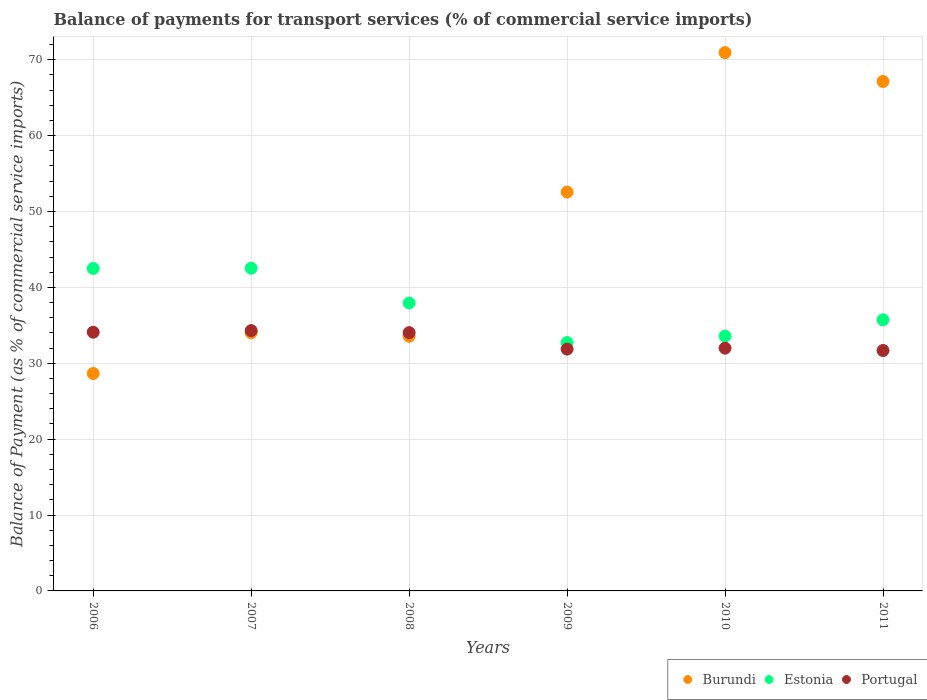Is the number of dotlines equal to the number of legend labels?
Ensure brevity in your answer.  Yes. What is the balance of payments for transport services in Portugal in 2007?
Provide a short and direct response. 34.3. Across all years, what is the maximum balance of payments for transport services in Portugal?
Keep it short and to the point. 34.3. Across all years, what is the minimum balance of payments for transport services in Portugal?
Provide a short and direct response. 31.68. In which year was the balance of payments for transport services in Burundi maximum?
Give a very brief answer. 2010. What is the total balance of payments for transport services in Portugal in the graph?
Provide a short and direct response. 197.95. What is the difference between the balance of payments for transport services in Estonia in 2006 and that in 2007?
Offer a terse response. -0.03. What is the difference between the balance of payments for transport services in Portugal in 2006 and the balance of payments for transport services in Burundi in 2008?
Make the answer very short. 0.53. What is the average balance of payments for transport services in Portugal per year?
Offer a very short reply. 32.99. In the year 2008, what is the difference between the balance of payments for transport services in Burundi and balance of payments for transport services in Portugal?
Your response must be concise. -0.47. In how many years, is the balance of payments for transport services in Burundi greater than 16 %?
Make the answer very short. 6. What is the ratio of the balance of payments for transport services in Burundi in 2006 to that in 2010?
Keep it short and to the point. 0.4. Is the balance of payments for transport services in Portugal in 2009 less than that in 2010?
Your answer should be compact. Yes. Is the difference between the balance of payments for transport services in Burundi in 2007 and 2009 greater than the difference between the balance of payments for transport services in Portugal in 2007 and 2009?
Your answer should be very brief. No. What is the difference between the highest and the second highest balance of payments for transport services in Portugal?
Keep it short and to the point. 0.21. What is the difference between the highest and the lowest balance of payments for transport services in Burundi?
Give a very brief answer. 42.28. Is the sum of the balance of payments for transport services in Estonia in 2010 and 2011 greater than the maximum balance of payments for transport services in Portugal across all years?
Your answer should be compact. Yes. Is it the case that in every year, the sum of the balance of payments for transport services in Portugal and balance of payments for transport services in Estonia  is greater than the balance of payments for transport services in Burundi?
Keep it short and to the point. No. Is the balance of payments for transport services in Estonia strictly greater than the balance of payments for transport services in Portugal over the years?
Keep it short and to the point. Yes. How many dotlines are there?
Provide a succinct answer. 3. Are the values on the major ticks of Y-axis written in scientific E-notation?
Your response must be concise. No. Does the graph contain any zero values?
Make the answer very short. No. Does the graph contain grids?
Your answer should be compact. Yes. Where does the legend appear in the graph?
Provide a succinct answer. Bottom right. How many legend labels are there?
Provide a succinct answer. 3. What is the title of the graph?
Keep it short and to the point. Balance of payments for transport services (% of commercial service imports). Does "Iceland" appear as one of the legend labels in the graph?
Your answer should be compact. No. What is the label or title of the Y-axis?
Your answer should be very brief. Balance of Payment (as % of commercial service imports). What is the Balance of Payment (as % of commercial service imports) of Burundi in 2006?
Offer a very short reply. 28.65. What is the Balance of Payment (as % of commercial service imports) of Estonia in 2006?
Ensure brevity in your answer.  42.49. What is the Balance of Payment (as % of commercial service imports) of Portugal in 2006?
Offer a terse response. 34.09. What is the Balance of Payment (as % of commercial service imports) of Burundi in 2007?
Ensure brevity in your answer.  34.02. What is the Balance of Payment (as % of commercial service imports) of Estonia in 2007?
Your answer should be very brief. 42.52. What is the Balance of Payment (as % of commercial service imports) in Portugal in 2007?
Your answer should be very brief. 34.3. What is the Balance of Payment (as % of commercial service imports) of Burundi in 2008?
Provide a short and direct response. 33.56. What is the Balance of Payment (as % of commercial service imports) in Estonia in 2008?
Give a very brief answer. 37.94. What is the Balance of Payment (as % of commercial service imports) of Portugal in 2008?
Offer a terse response. 34.03. What is the Balance of Payment (as % of commercial service imports) in Burundi in 2009?
Ensure brevity in your answer.  52.56. What is the Balance of Payment (as % of commercial service imports) in Estonia in 2009?
Your answer should be very brief. 32.73. What is the Balance of Payment (as % of commercial service imports) of Portugal in 2009?
Keep it short and to the point. 31.86. What is the Balance of Payment (as % of commercial service imports) in Burundi in 2010?
Offer a very short reply. 70.93. What is the Balance of Payment (as % of commercial service imports) of Estonia in 2010?
Keep it short and to the point. 33.58. What is the Balance of Payment (as % of commercial service imports) of Portugal in 2010?
Offer a terse response. 31.99. What is the Balance of Payment (as % of commercial service imports) of Burundi in 2011?
Make the answer very short. 67.13. What is the Balance of Payment (as % of commercial service imports) in Estonia in 2011?
Make the answer very short. 35.73. What is the Balance of Payment (as % of commercial service imports) of Portugal in 2011?
Provide a succinct answer. 31.68. Across all years, what is the maximum Balance of Payment (as % of commercial service imports) in Burundi?
Ensure brevity in your answer.  70.93. Across all years, what is the maximum Balance of Payment (as % of commercial service imports) in Estonia?
Keep it short and to the point. 42.52. Across all years, what is the maximum Balance of Payment (as % of commercial service imports) in Portugal?
Your answer should be very brief. 34.3. Across all years, what is the minimum Balance of Payment (as % of commercial service imports) in Burundi?
Your response must be concise. 28.65. Across all years, what is the minimum Balance of Payment (as % of commercial service imports) in Estonia?
Provide a short and direct response. 32.73. Across all years, what is the minimum Balance of Payment (as % of commercial service imports) in Portugal?
Offer a very short reply. 31.68. What is the total Balance of Payment (as % of commercial service imports) of Burundi in the graph?
Your response must be concise. 286.85. What is the total Balance of Payment (as % of commercial service imports) in Estonia in the graph?
Your response must be concise. 224.98. What is the total Balance of Payment (as % of commercial service imports) of Portugal in the graph?
Provide a succinct answer. 197.95. What is the difference between the Balance of Payment (as % of commercial service imports) of Burundi in 2006 and that in 2007?
Give a very brief answer. -5.37. What is the difference between the Balance of Payment (as % of commercial service imports) in Estonia in 2006 and that in 2007?
Your answer should be compact. -0.03. What is the difference between the Balance of Payment (as % of commercial service imports) of Portugal in 2006 and that in 2007?
Give a very brief answer. -0.21. What is the difference between the Balance of Payment (as % of commercial service imports) of Burundi in 2006 and that in 2008?
Offer a terse response. -4.91. What is the difference between the Balance of Payment (as % of commercial service imports) in Estonia in 2006 and that in 2008?
Ensure brevity in your answer.  4.55. What is the difference between the Balance of Payment (as % of commercial service imports) of Portugal in 2006 and that in 2008?
Provide a short and direct response. 0.06. What is the difference between the Balance of Payment (as % of commercial service imports) in Burundi in 2006 and that in 2009?
Keep it short and to the point. -23.9. What is the difference between the Balance of Payment (as % of commercial service imports) in Estonia in 2006 and that in 2009?
Your response must be concise. 9.76. What is the difference between the Balance of Payment (as % of commercial service imports) in Portugal in 2006 and that in 2009?
Your answer should be compact. 2.23. What is the difference between the Balance of Payment (as % of commercial service imports) of Burundi in 2006 and that in 2010?
Your answer should be very brief. -42.28. What is the difference between the Balance of Payment (as % of commercial service imports) of Estonia in 2006 and that in 2010?
Make the answer very short. 8.91. What is the difference between the Balance of Payment (as % of commercial service imports) of Portugal in 2006 and that in 2010?
Your response must be concise. 2.1. What is the difference between the Balance of Payment (as % of commercial service imports) of Burundi in 2006 and that in 2011?
Make the answer very short. -38.48. What is the difference between the Balance of Payment (as % of commercial service imports) in Estonia in 2006 and that in 2011?
Provide a succinct answer. 6.76. What is the difference between the Balance of Payment (as % of commercial service imports) of Portugal in 2006 and that in 2011?
Provide a succinct answer. 2.41. What is the difference between the Balance of Payment (as % of commercial service imports) of Burundi in 2007 and that in 2008?
Ensure brevity in your answer.  0.46. What is the difference between the Balance of Payment (as % of commercial service imports) of Estonia in 2007 and that in 2008?
Your response must be concise. 4.58. What is the difference between the Balance of Payment (as % of commercial service imports) of Portugal in 2007 and that in 2008?
Provide a succinct answer. 0.27. What is the difference between the Balance of Payment (as % of commercial service imports) of Burundi in 2007 and that in 2009?
Offer a very short reply. -18.54. What is the difference between the Balance of Payment (as % of commercial service imports) in Estonia in 2007 and that in 2009?
Provide a short and direct response. 9.79. What is the difference between the Balance of Payment (as % of commercial service imports) in Portugal in 2007 and that in 2009?
Your response must be concise. 2.44. What is the difference between the Balance of Payment (as % of commercial service imports) in Burundi in 2007 and that in 2010?
Offer a terse response. -36.91. What is the difference between the Balance of Payment (as % of commercial service imports) in Estonia in 2007 and that in 2010?
Your response must be concise. 8.94. What is the difference between the Balance of Payment (as % of commercial service imports) of Portugal in 2007 and that in 2010?
Your response must be concise. 2.31. What is the difference between the Balance of Payment (as % of commercial service imports) in Burundi in 2007 and that in 2011?
Offer a very short reply. -33.11. What is the difference between the Balance of Payment (as % of commercial service imports) of Estonia in 2007 and that in 2011?
Your response must be concise. 6.79. What is the difference between the Balance of Payment (as % of commercial service imports) in Portugal in 2007 and that in 2011?
Your answer should be compact. 2.62. What is the difference between the Balance of Payment (as % of commercial service imports) of Burundi in 2008 and that in 2009?
Give a very brief answer. -18.99. What is the difference between the Balance of Payment (as % of commercial service imports) in Estonia in 2008 and that in 2009?
Your answer should be compact. 5.21. What is the difference between the Balance of Payment (as % of commercial service imports) in Portugal in 2008 and that in 2009?
Offer a terse response. 2.17. What is the difference between the Balance of Payment (as % of commercial service imports) in Burundi in 2008 and that in 2010?
Provide a short and direct response. -37.37. What is the difference between the Balance of Payment (as % of commercial service imports) in Estonia in 2008 and that in 2010?
Your answer should be compact. 4.36. What is the difference between the Balance of Payment (as % of commercial service imports) of Portugal in 2008 and that in 2010?
Offer a terse response. 2.05. What is the difference between the Balance of Payment (as % of commercial service imports) of Burundi in 2008 and that in 2011?
Provide a succinct answer. -33.57. What is the difference between the Balance of Payment (as % of commercial service imports) in Estonia in 2008 and that in 2011?
Keep it short and to the point. 2.21. What is the difference between the Balance of Payment (as % of commercial service imports) in Portugal in 2008 and that in 2011?
Provide a succinct answer. 2.36. What is the difference between the Balance of Payment (as % of commercial service imports) of Burundi in 2009 and that in 2010?
Your answer should be very brief. -18.38. What is the difference between the Balance of Payment (as % of commercial service imports) in Estonia in 2009 and that in 2010?
Make the answer very short. -0.85. What is the difference between the Balance of Payment (as % of commercial service imports) of Portugal in 2009 and that in 2010?
Provide a short and direct response. -0.13. What is the difference between the Balance of Payment (as % of commercial service imports) of Burundi in 2009 and that in 2011?
Provide a succinct answer. -14.58. What is the difference between the Balance of Payment (as % of commercial service imports) in Estonia in 2009 and that in 2011?
Provide a short and direct response. -3. What is the difference between the Balance of Payment (as % of commercial service imports) in Portugal in 2009 and that in 2011?
Your answer should be compact. 0.18. What is the difference between the Balance of Payment (as % of commercial service imports) of Burundi in 2010 and that in 2011?
Keep it short and to the point. 3.8. What is the difference between the Balance of Payment (as % of commercial service imports) of Estonia in 2010 and that in 2011?
Your response must be concise. -2.15. What is the difference between the Balance of Payment (as % of commercial service imports) in Portugal in 2010 and that in 2011?
Your response must be concise. 0.31. What is the difference between the Balance of Payment (as % of commercial service imports) in Burundi in 2006 and the Balance of Payment (as % of commercial service imports) in Estonia in 2007?
Provide a succinct answer. -13.87. What is the difference between the Balance of Payment (as % of commercial service imports) in Burundi in 2006 and the Balance of Payment (as % of commercial service imports) in Portugal in 2007?
Your answer should be compact. -5.65. What is the difference between the Balance of Payment (as % of commercial service imports) in Estonia in 2006 and the Balance of Payment (as % of commercial service imports) in Portugal in 2007?
Make the answer very short. 8.19. What is the difference between the Balance of Payment (as % of commercial service imports) of Burundi in 2006 and the Balance of Payment (as % of commercial service imports) of Estonia in 2008?
Offer a very short reply. -9.29. What is the difference between the Balance of Payment (as % of commercial service imports) in Burundi in 2006 and the Balance of Payment (as % of commercial service imports) in Portugal in 2008?
Provide a succinct answer. -5.38. What is the difference between the Balance of Payment (as % of commercial service imports) in Estonia in 2006 and the Balance of Payment (as % of commercial service imports) in Portugal in 2008?
Offer a terse response. 8.46. What is the difference between the Balance of Payment (as % of commercial service imports) of Burundi in 2006 and the Balance of Payment (as % of commercial service imports) of Estonia in 2009?
Offer a terse response. -4.08. What is the difference between the Balance of Payment (as % of commercial service imports) of Burundi in 2006 and the Balance of Payment (as % of commercial service imports) of Portugal in 2009?
Provide a short and direct response. -3.21. What is the difference between the Balance of Payment (as % of commercial service imports) of Estonia in 2006 and the Balance of Payment (as % of commercial service imports) of Portugal in 2009?
Provide a short and direct response. 10.63. What is the difference between the Balance of Payment (as % of commercial service imports) in Burundi in 2006 and the Balance of Payment (as % of commercial service imports) in Estonia in 2010?
Offer a very short reply. -4.92. What is the difference between the Balance of Payment (as % of commercial service imports) of Burundi in 2006 and the Balance of Payment (as % of commercial service imports) of Portugal in 2010?
Make the answer very short. -3.34. What is the difference between the Balance of Payment (as % of commercial service imports) in Estonia in 2006 and the Balance of Payment (as % of commercial service imports) in Portugal in 2010?
Provide a succinct answer. 10.5. What is the difference between the Balance of Payment (as % of commercial service imports) in Burundi in 2006 and the Balance of Payment (as % of commercial service imports) in Estonia in 2011?
Offer a terse response. -7.08. What is the difference between the Balance of Payment (as % of commercial service imports) of Burundi in 2006 and the Balance of Payment (as % of commercial service imports) of Portugal in 2011?
Make the answer very short. -3.03. What is the difference between the Balance of Payment (as % of commercial service imports) in Estonia in 2006 and the Balance of Payment (as % of commercial service imports) in Portugal in 2011?
Ensure brevity in your answer.  10.81. What is the difference between the Balance of Payment (as % of commercial service imports) of Burundi in 2007 and the Balance of Payment (as % of commercial service imports) of Estonia in 2008?
Your answer should be very brief. -3.92. What is the difference between the Balance of Payment (as % of commercial service imports) of Burundi in 2007 and the Balance of Payment (as % of commercial service imports) of Portugal in 2008?
Your answer should be very brief. -0.02. What is the difference between the Balance of Payment (as % of commercial service imports) of Estonia in 2007 and the Balance of Payment (as % of commercial service imports) of Portugal in 2008?
Provide a succinct answer. 8.49. What is the difference between the Balance of Payment (as % of commercial service imports) of Burundi in 2007 and the Balance of Payment (as % of commercial service imports) of Estonia in 2009?
Ensure brevity in your answer.  1.29. What is the difference between the Balance of Payment (as % of commercial service imports) of Burundi in 2007 and the Balance of Payment (as % of commercial service imports) of Portugal in 2009?
Give a very brief answer. 2.16. What is the difference between the Balance of Payment (as % of commercial service imports) in Estonia in 2007 and the Balance of Payment (as % of commercial service imports) in Portugal in 2009?
Offer a terse response. 10.66. What is the difference between the Balance of Payment (as % of commercial service imports) of Burundi in 2007 and the Balance of Payment (as % of commercial service imports) of Estonia in 2010?
Your response must be concise. 0.44. What is the difference between the Balance of Payment (as % of commercial service imports) in Burundi in 2007 and the Balance of Payment (as % of commercial service imports) in Portugal in 2010?
Your answer should be compact. 2.03. What is the difference between the Balance of Payment (as % of commercial service imports) of Estonia in 2007 and the Balance of Payment (as % of commercial service imports) of Portugal in 2010?
Ensure brevity in your answer.  10.53. What is the difference between the Balance of Payment (as % of commercial service imports) of Burundi in 2007 and the Balance of Payment (as % of commercial service imports) of Estonia in 2011?
Make the answer very short. -1.71. What is the difference between the Balance of Payment (as % of commercial service imports) in Burundi in 2007 and the Balance of Payment (as % of commercial service imports) in Portugal in 2011?
Offer a very short reply. 2.34. What is the difference between the Balance of Payment (as % of commercial service imports) of Estonia in 2007 and the Balance of Payment (as % of commercial service imports) of Portugal in 2011?
Your answer should be very brief. 10.84. What is the difference between the Balance of Payment (as % of commercial service imports) of Burundi in 2008 and the Balance of Payment (as % of commercial service imports) of Estonia in 2009?
Keep it short and to the point. 0.83. What is the difference between the Balance of Payment (as % of commercial service imports) in Burundi in 2008 and the Balance of Payment (as % of commercial service imports) in Portugal in 2009?
Give a very brief answer. 1.7. What is the difference between the Balance of Payment (as % of commercial service imports) of Estonia in 2008 and the Balance of Payment (as % of commercial service imports) of Portugal in 2009?
Give a very brief answer. 6.08. What is the difference between the Balance of Payment (as % of commercial service imports) in Burundi in 2008 and the Balance of Payment (as % of commercial service imports) in Estonia in 2010?
Ensure brevity in your answer.  -0.02. What is the difference between the Balance of Payment (as % of commercial service imports) of Burundi in 2008 and the Balance of Payment (as % of commercial service imports) of Portugal in 2010?
Your answer should be very brief. 1.57. What is the difference between the Balance of Payment (as % of commercial service imports) of Estonia in 2008 and the Balance of Payment (as % of commercial service imports) of Portugal in 2010?
Provide a succinct answer. 5.95. What is the difference between the Balance of Payment (as % of commercial service imports) in Burundi in 2008 and the Balance of Payment (as % of commercial service imports) in Estonia in 2011?
Provide a succinct answer. -2.17. What is the difference between the Balance of Payment (as % of commercial service imports) in Burundi in 2008 and the Balance of Payment (as % of commercial service imports) in Portugal in 2011?
Keep it short and to the point. 1.88. What is the difference between the Balance of Payment (as % of commercial service imports) in Estonia in 2008 and the Balance of Payment (as % of commercial service imports) in Portugal in 2011?
Offer a terse response. 6.26. What is the difference between the Balance of Payment (as % of commercial service imports) in Burundi in 2009 and the Balance of Payment (as % of commercial service imports) in Estonia in 2010?
Your answer should be compact. 18.98. What is the difference between the Balance of Payment (as % of commercial service imports) of Burundi in 2009 and the Balance of Payment (as % of commercial service imports) of Portugal in 2010?
Ensure brevity in your answer.  20.57. What is the difference between the Balance of Payment (as % of commercial service imports) in Estonia in 2009 and the Balance of Payment (as % of commercial service imports) in Portugal in 2010?
Provide a succinct answer. 0.74. What is the difference between the Balance of Payment (as % of commercial service imports) in Burundi in 2009 and the Balance of Payment (as % of commercial service imports) in Estonia in 2011?
Offer a terse response. 16.83. What is the difference between the Balance of Payment (as % of commercial service imports) of Burundi in 2009 and the Balance of Payment (as % of commercial service imports) of Portugal in 2011?
Make the answer very short. 20.88. What is the difference between the Balance of Payment (as % of commercial service imports) of Estonia in 2009 and the Balance of Payment (as % of commercial service imports) of Portugal in 2011?
Provide a short and direct response. 1.05. What is the difference between the Balance of Payment (as % of commercial service imports) in Burundi in 2010 and the Balance of Payment (as % of commercial service imports) in Estonia in 2011?
Give a very brief answer. 35.2. What is the difference between the Balance of Payment (as % of commercial service imports) in Burundi in 2010 and the Balance of Payment (as % of commercial service imports) in Portugal in 2011?
Ensure brevity in your answer.  39.25. What is the difference between the Balance of Payment (as % of commercial service imports) of Estonia in 2010 and the Balance of Payment (as % of commercial service imports) of Portugal in 2011?
Offer a very short reply. 1.9. What is the average Balance of Payment (as % of commercial service imports) in Burundi per year?
Give a very brief answer. 47.81. What is the average Balance of Payment (as % of commercial service imports) in Estonia per year?
Keep it short and to the point. 37.5. What is the average Balance of Payment (as % of commercial service imports) in Portugal per year?
Provide a succinct answer. 32.99. In the year 2006, what is the difference between the Balance of Payment (as % of commercial service imports) in Burundi and Balance of Payment (as % of commercial service imports) in Estonia?
Your answer should be compact. -13.84. In the year 2006, what is the difference between the Balance of Payment (as % of commercial service imports) of Burundi and Balance of Payment (as % of commercial service imports) of Portugal?
Make the answer very short. -5.44. In the year 2006, what is the difference between the Balance of Payment (as % of commercial service imports) in Estonia and Balance of Payment (as % of commercial service imports) in Portugal?
Give a very brief answer. 8.4. In the year 2007, what is the difference between the Balance of Payment (as % of commercial service imports) in Burundi and Balance of Payment (as % of commercial service imports) in Estonia?
Ensure brevity in your answer.  -8.5. In the year 2007, what is the difference between the Balance of Payment (as % of commercial service imports) in Burundi and Balance of Payment (as % of commercial service imports) in Portugal?
Your answer should be very brief. -0.29. In the year 2007, what is the difference between the Balance of Payment (as % of commercial service imports) in Estonia and Balance of Payment (as % of commercial service imports) in Portugal?
Provide a succinct answer. 8.22. In the year 2008, what is the difference between the Balance of Payment (as % of commercial service imports) of Burundi and Balance of Payment (as % of commercial service imports) of Estonia?
Your answer should be compact. -4.38. In the year 2008, what is the difference between the Balance of Payment (as % of commercial service imports) in Burundi and Balance of Payment (as % of commercial service imports) in Portugal?
Provide a succinct answer. -0.47. In the year 2008, what is the difference between the Balance of Payment (as % of commercial service imports) of Estonia and Balance of Payment (as % of commercial service imports) of Portugal?
Offer a terse response. 3.9. In the year 2009, what is the difference between the Balance of Payment (as % of commercial service imports) in Burundi and Balance of Payment (as % of commercial service imports) in Estonia?
Ensure brevity in your answer.  19.83. In the year 2009, what is the difference between the Balance of Payment (as % of commercial service imports) in Burundi and Balance of Payment (as % of commercial service imports) in Portugal?
Offer a terse response. 20.69. In the year 2009, what is the difference between the Balance of Payment (as % of commercial service imports) in Estonia and Balance of Payment (as % of commercial service imports) in Portugal?
Offer a terse response. 0.87. In the year 2010, what is the difference between the Balance of Payment (as % of commercial service imports) in Burundi and Balance of Payment (as % of commercial service imports) in Estonia?
Your answer should be very brief. 37.35. In the year 2010, what is the difference between the Balance of Payment (as % of commercial service imports) of Burundi and Balance of Payment (as % of commercial service imports) of Portugal?
Your answer should be very brief. 38.94. In the year 2010, what is the difference between the Balance of Payment (as % of commercial service imports) of Estonia and Balance of Payment (as % of commercial service imports) of Portugal?
Ensure brevity in your answer.  1.59. In the year 2011, what is the difference between the Balance of Payment (as % of commercial service imports) in Burundi and Balance of Payment (as % of commercial service imports) in Estonia?
Provide a short and direct response. 31.4. In the year 2011, what is the difference between the Balance of Payment (as % of commercial service imports) of Burundi and Balance of Payment (as % of commercial service imports) of Portugal?
Your answer should be compact. 35.45. In the year 2011, what is the difference between the Balance of Payment (as % of commercial service imports) in Estonia and Balance of Payment (as % of commercial service imports) in Portugal?
Offer a terse response. 4.05. What is the ratio of the Balance of Payment (as % of commercial service imports) in Burundi in 2006 to that in 2007?
Offer a very short reply. 0.84. What is the ratio of the Balance of Payment (as % of commercial service imports) in Burundi in 2006 to that in 2008?
Provide a short and direct response. 0.85. What is the ratio of the Balance of Payment (as % of commercial service imports) of Estonia in 2006 to that in 2008?
Keep it short and to the point. 1.12. What is the ratio of the Balance of Payment (as % of commercial service imports) in Burundi in 2006 to that in 2009?
Provide a succinct answer. 0.55. What is the ratio of the Balance of Payment (as % of commercial service imports) of Estonia in 2006 to that in 2009?
Your response must be concise. 1.3. What is the ratio of the Balance of Payment (as % of commercial service imports) in Portugal in 2006 to that in 2009?
Make the answer very short. 1.07. What is the ratio of the Balance of Payment (as % of commercial service imports) of Burundi in 2006 to that in 2010?
Your answer should be compact. 0.4. What is the ratio of the Balance of Payment (as % of commercial service imports) of Estonia in 2006 to that in 2010?
Provide a short and direct response. 1.27. What is the ratio of the Balance of Payment (as % of commercial service imports) of Portugal in 2006 to that in 2010?
Your answer should be compact. 1.07. What is the ratio of the Balance of Payment (as % of commercial service imports) in Burundi in 2006 to that in 2011?
Make the answer very short. 0.43. What is the ratio of the Balance of Payment (as % of commercial service imports) in Estonia in 2006 to that in 2011?
Provide a short and direct response. 1.19. What is the ratio of the Balance of Payment (as % of commercial service imports) in Portugal in 2006 to that in 2011?
Ensure brevity in your answer.  1.08. What is the ratio of the Balance of Payment (as % of commercial service imports) of Burundi in 2007 to that in 2008?
Keep it short and to the point. 1.01. What is the ratio of the Balance of Payment (as % of commercial service imports) of Estonia in 2007 to that in 2008?
Give a very brief answer. 1.12. What is the ratio of the Balance of Payment (as % of commercial service imports) in Portugal in 2007 to that in 2008?
Your response must be concise. 1.01. What is the ratio of the Balance of Payment (as % of commercial service imports) of Burundi in 2007 to that in 2009?
Provide a short and direct response. 0.65. What is the ratio of the Balance of Payment (as % of commercial service imports) of Estonia in 2007 to that in 2009?
Give a very brief answer. 1.3. What is the ratio of the Balance of Payment (as % of commercial service imports) of Portugal in 2007 to that in 2009?
Keep it short and to the point. 1.08. What is the ratio of the Balance of Payment (as % of commercial service imports) of Burundi in 2007 to that in 2010?
Provide a succinct answer. 0.48. What is the ratio of the Balance of Payment (as % of commercial service imports) of Estonia in 2007 to that in 2010?
Your answer should be very brief. 1.27. What is the ratio of the Balance of Payment (as % of commercial service imports) of Portugal in 2007 to that in 2010?
Offer a terse response. 1.07. What is the ratio of the Balance of Payment (as % of commercial service imports) in Burundi in 2007 to that in 2011?
Provide a succinct answer. 0.51. What is the ratio of the Balance of Payment (as % of commercial service imports) of Estonia in 2007 to that in 2011?
Your response must be concise. 1.19. What is the ratio of the Balance of Payment (as % of commercial service imports) of Portugal in 2007 to that in 2011?
Provide a succinct answer. 1.08. What is the ratio of the Balance of Payment (as % of commercial service imports) in Burundi in 2008 to that in 2009?
Ensure brevity in your answer.  0.64. What is the ratio of the Balance of Payment (as % of commercial service imports) in Estonia in 2008 to that in 2009?
Offer a very short reply. 1.16. What is the ratio of the Balance of Payment (as % of commercial service imports) of Portugal in 2008 to that in 2009?
Your answer should be compact. 1.07. What is the ratio of the Balance of Payment (as % of commercial service imports) of Burundi in 2008 to that in 2010?
Keep it short and to the point. 0.47. What is the ratio of the Balance of Payment (as % of commercial service imports) in Estonia in 2008 to that in 2010?
Offer a very short reply. 1.13. What is the ratio of the Balance of Payment (as % of commercial service imports) of Portugal in 2008 to that in 2010?
Make the answer very short. 1.06. What is the ratio of the Balance of Payment (as % of commercial service imports) of Burundi in 2008 to that in 2011?
Offer a very short reply. 0.5. What is the ratio of the Balance of Payment (as % of commercial service imports) in Estonia in 2008 to that in 2011?
Offer a very short reply. 1.06. What is the ratio of the Balance of Payment (as % of commercial service imports) in Portugal in 2008 to that in 2011?
Offer a very short reply. 1.07. What is the ratio of the Balance of Payment (as % of commercial service imports) of Burundi in 2009 to that in 2010?
Your answer should be very brief. 0.74. What is the ratio of the Balance of Payment (as % of commercial service imports) in Estonia in 2009 to that in 2010?
Your answer should be compact. 0.97. What is the ratio of the Balance of Payment (as % of commercial service imports) in Burundi in 2009 to that in 2011?
Your response must be concise. 0.78. What is the ratio of the Balance of Payment (as % of commercial service imports) of Estonia in 2009 to that in 2011?
Provide a short and direct response. 0.92. What is the ratio of the Balance of Payment (as % of commercial service imports) of Burundi in 2010 to that in 2011?
Give a very brief answer. 1.06. What is the ratio of the Balance of Payment (as % of commercial service imports) of Estonia in 2010 to that in 2011?
Your answer should be compact. 0.94. What is the ratio of the Balance of Payment (as % of commercial service imports) of Portugal in 2010 to that in 2011?
Offer a terse response. 1.01. What is the difference between the highest and the second highest Balance of Payment (as % of commercial service imports) of Burundi?
Provide a short and direct response. 3.8. What is the difference between the highest and the second highest Balance of Payment (as % of commercial service imports) in Estonia?
Give a very brief answer. 0.03. What is the difference between the highest and the second highest Balance of Payment (as % of commercial service imports) in Portugal?
Provide a short and direct response. 0.21. What is the difference between the highest and the lowest Balance of Payment (as % of commercial service imports) of Burundi?
Offer a terse response. 42.28. What is the difference between the highest and the lowest Balance of Payment (as % of commercial service imports) in Estonia?
Your answer should be very brief. 9.79. What is the difference between the highest and the lowest Balance of Payment (as % of commercial service imports) of Portugal?
Offer a very short reply. 2.62. 